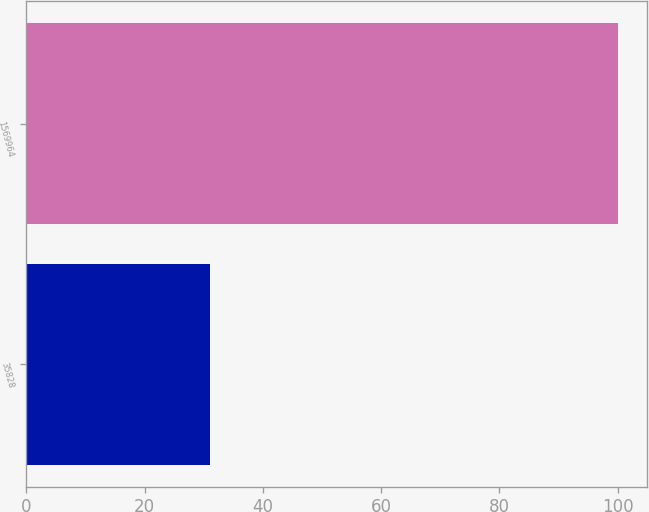Convert chart. <chart><loc_0><loc_0><loc_500><loc_500><bar_chart><fcel>35828<fcel>1569964<nl><fcel>31<fcel>100<nl></chart> 